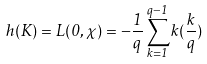Convert formula to latex. <formula><loc_0><loc_0><loc_500><loc_500>h ( K ) = L ( 0 , \chi ) = - \frac { 1 } { q } \sum _ { k = 1 } ^ { q - 1 } k ( \frac { k } { q } )</formula> 